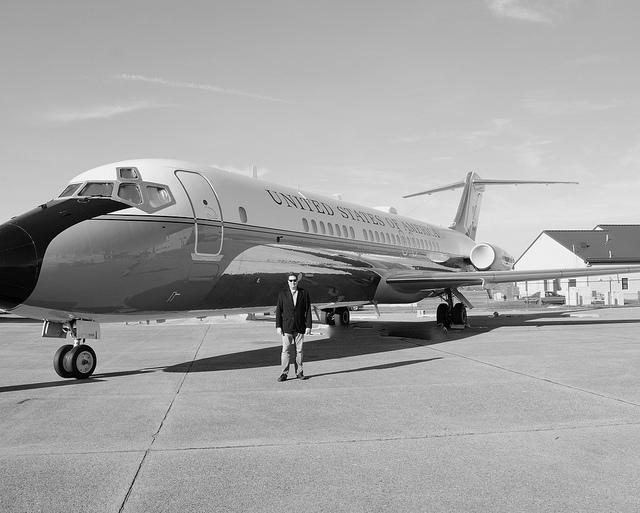How many wheels does the airplane have?
Give a very brief answer. 6. How many people are there?
Give a very brief answer. 1. How many blue buses are there?
Give a very brief answer. 0. 